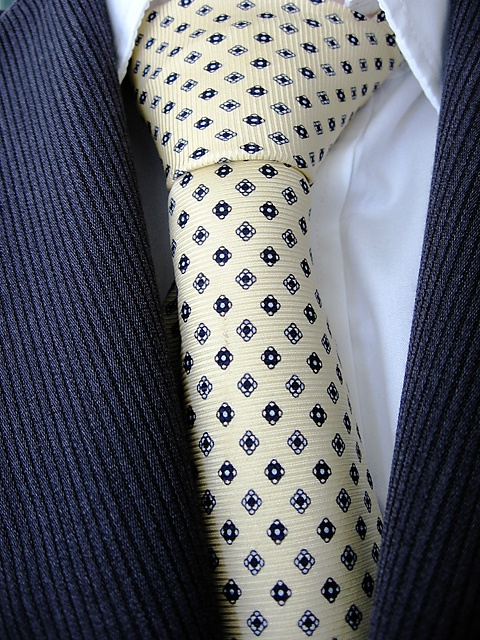Describe the objects in this image and their specific colors. I can see a tie in gray, beige, darkgray, and black tones in this image. 